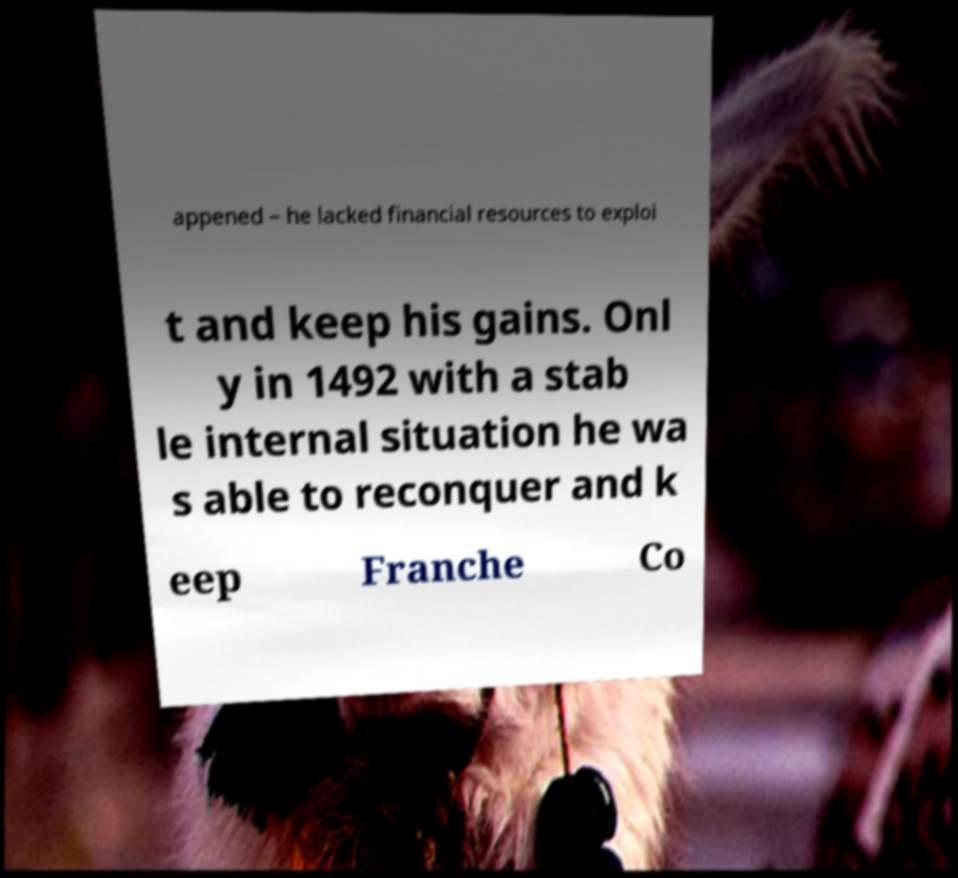Please read and relay the text visible in this image. What does it say? appened – he lacked financial resources to exploi t and keep his gains. Onl y in 1492 with a stab le internal situation he wa s able to reconquer and k eep Franche Co 